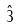<formula> <loc_0><loc_0><loc_500><loc_500>\hat { 3 }</formula> 